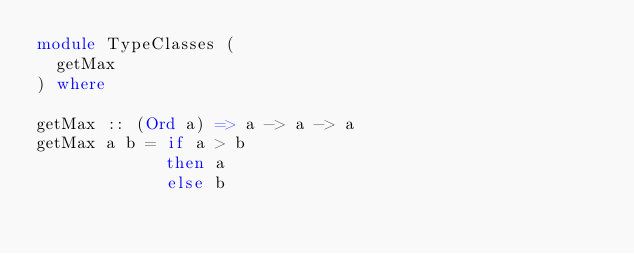Convert code to text. <code><loc_0><loc_0><loc_500><loc_500><_Haskell_>module TypeClasses (
  getMax
) where

getMax :: (Ord a) => a -> a -> a
getMax a b = if a > b
             then a
             else b</code> 